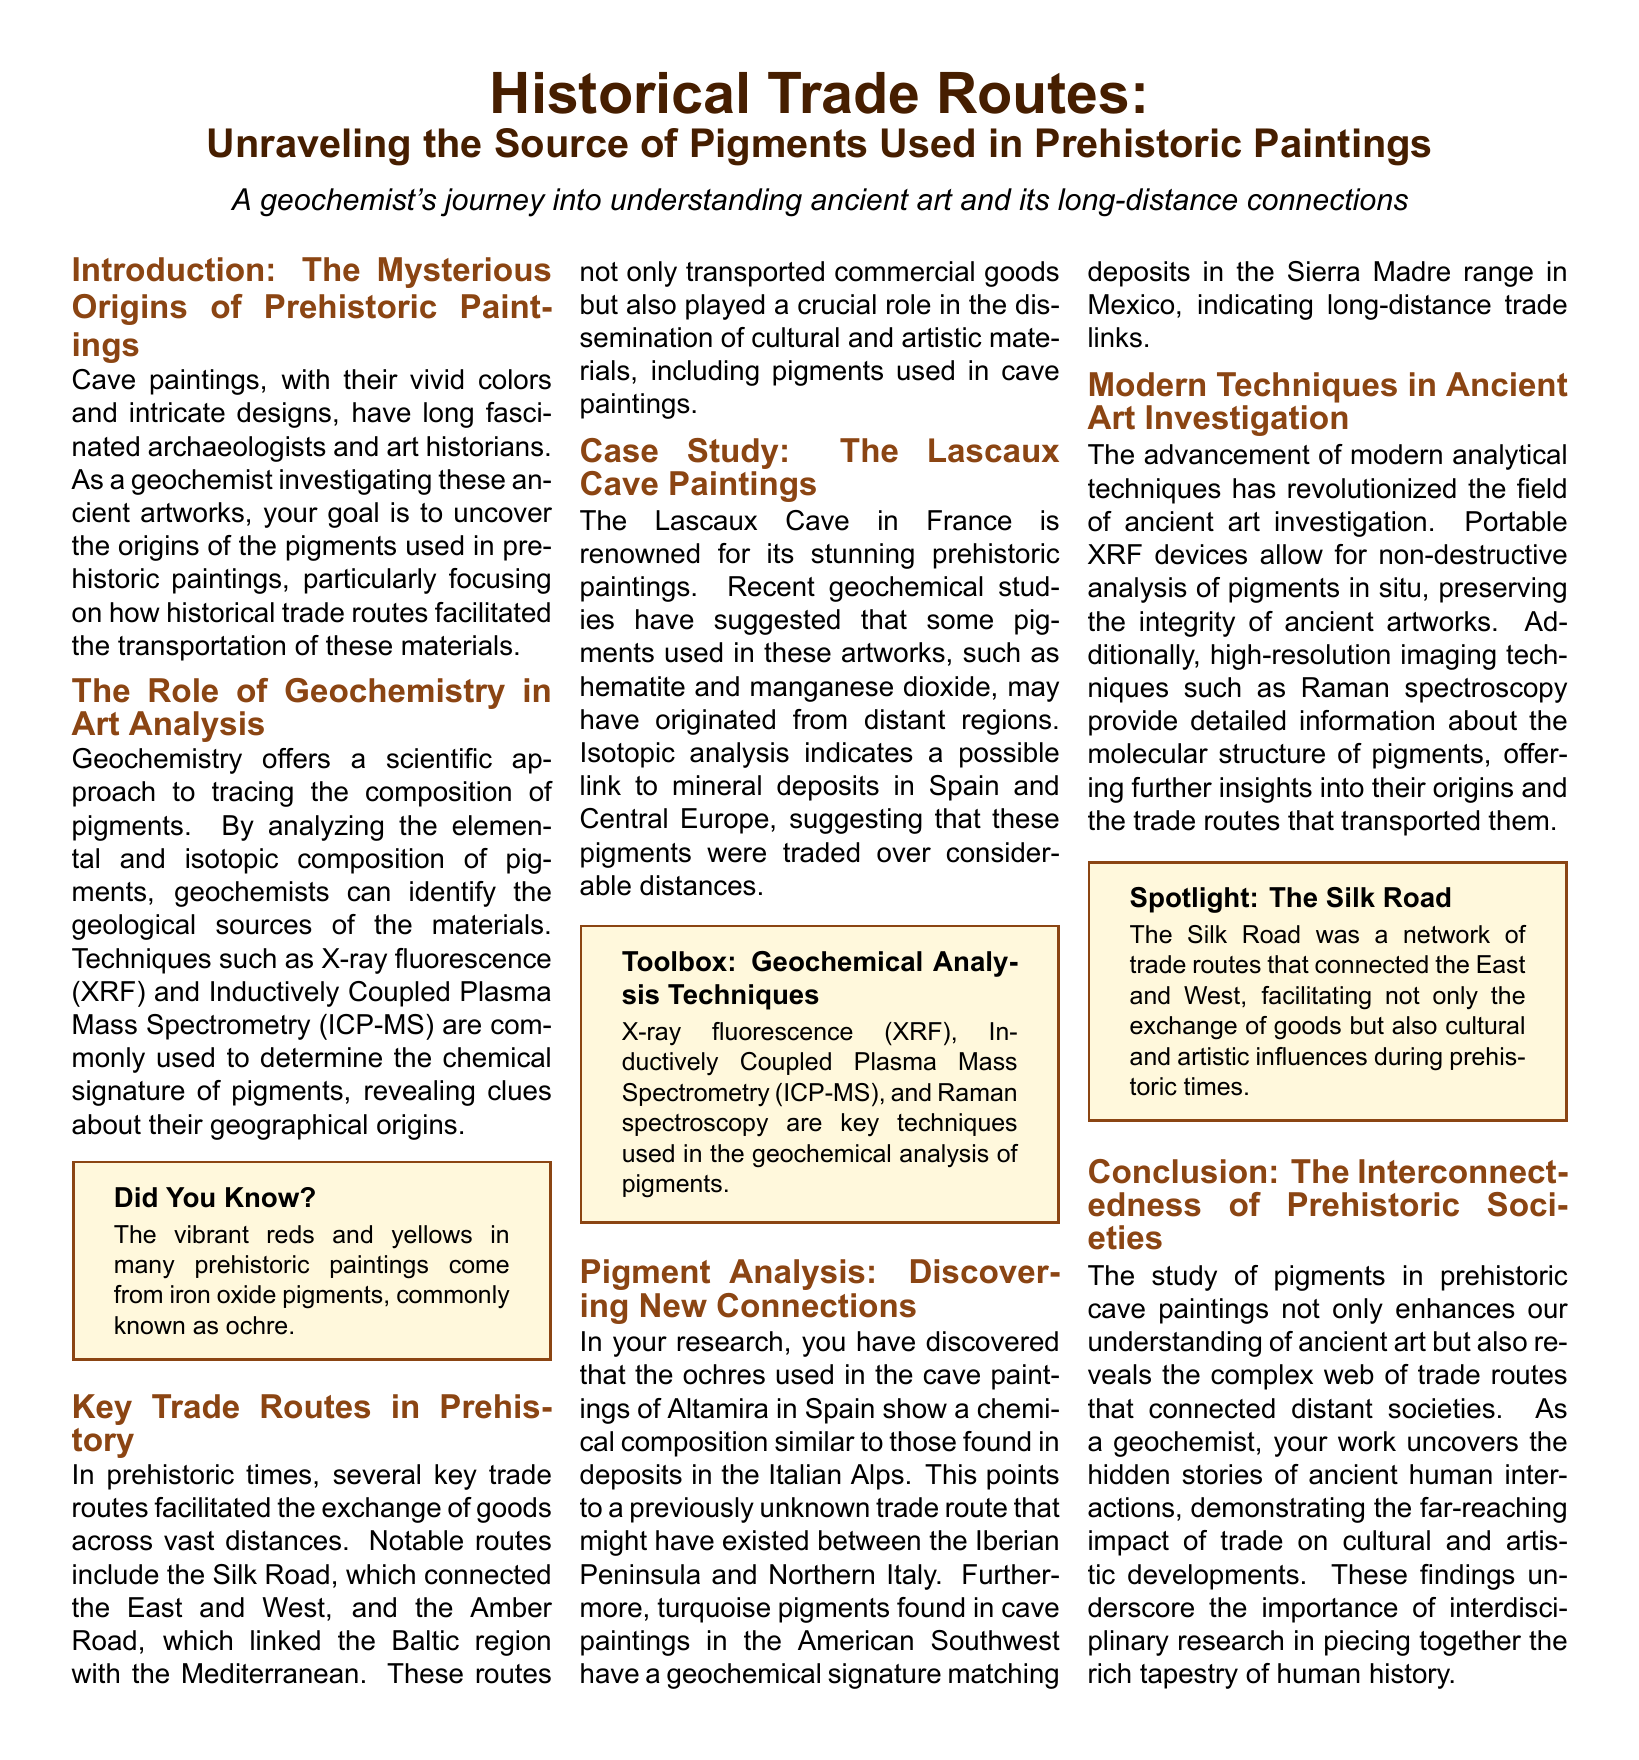What is the main aim of the geochemist? The document states that the geochemist's aim is to uncover the origins of the pigments used in prehistoric paintings.
Answer: uncover the origins of the pigments What techniques are used in geochemical analysis? According to the document, techniques such as X-ray fluorescence (XRF) and Inductively Coupled Plasma Mass Spectrometry (ICP-MS) are commonly used.
Answer: X-ray fluorescence (XRF) and Inductively Coupled Plasma Mass Spectrometry (ICP-MS) Which cave is known for its stunning prehistoric paintings? The document specifically mentions the Lascaux Cave in France as renowned for its prehistoric paintings.
Answer: Lascaux Cave What similar sources were found in the ochres of Altamira cave paintings? The document points out that ochres in Altamira show a chemical composition similar to deposits in the Italian Alps.
Answer: Italian Alps Which trade route connected the Baltic region with the Mediterranean? The document indicates that the Amber Road linked the Baltic region with the Mediterranean.
Answer: Amber Road What has revolutionized ancient art investigation? The document highlights that the advancement of modern analytical techniques has revolutionized the field.
Answer: modern analytical techniques What kind of analysis do portable XRF devices allow for? The document states that portable XRF devices allow for non-destructive analysis of pigments in situ.
Answer: non-destructive analysis What is the significance of studying pigments in prehistoric cave paintings? The document emphasizes that it enhances our understanding of ancient art and reveals trade routes connecting distant societies.
Answer: enhances understanding of ancient art and reveals trade routes 